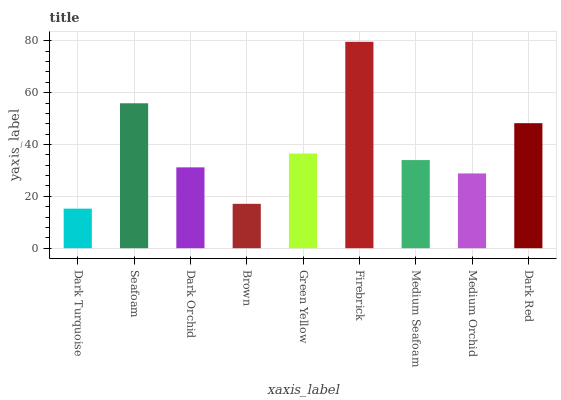Is Dark Turquoise the minimum?
Answer yes or no. Yes. Is Firebrick the maximum?
Answer yes or no. Yes. Is Seafoam the minimum?
Answer yes or no. No. Is Seafoam the maximum?
Answer yes or no. No. Is Seafoam greater than Dark Turquoise?
Answer yes or no. Yes. Is Dark Turquoise less than Seafoam?
Answer yes or no. Yes. Is Dark Turquoise greater than Seafoam?
Answer yes or no. No. Is Seafoam less than Dark Turquoise?
Answer yes or no. No. Is Medium Seafoam the high median?
Answer yes or no. Yes. Is Medium Seafoam the low median?
Answer yes or no. Yes. Is Seafoam the high median?
Answer yes or no. No. Is Firebrick the low median?
Answer yes or no. No. 